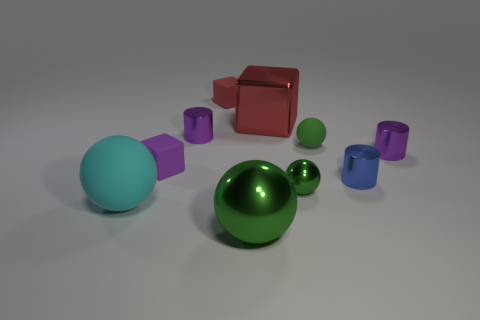What can you tell me about the shapes and colors in this image? The image showcases a collection of geometric shapes in various colors, creating a vibrant scene. We see spheres, cubes, and cylinders, featuring hues like cyan, green, purple, and red. Each shape's color adds a unique visual dimension to the arrangement, suggesting a study of form and color. 